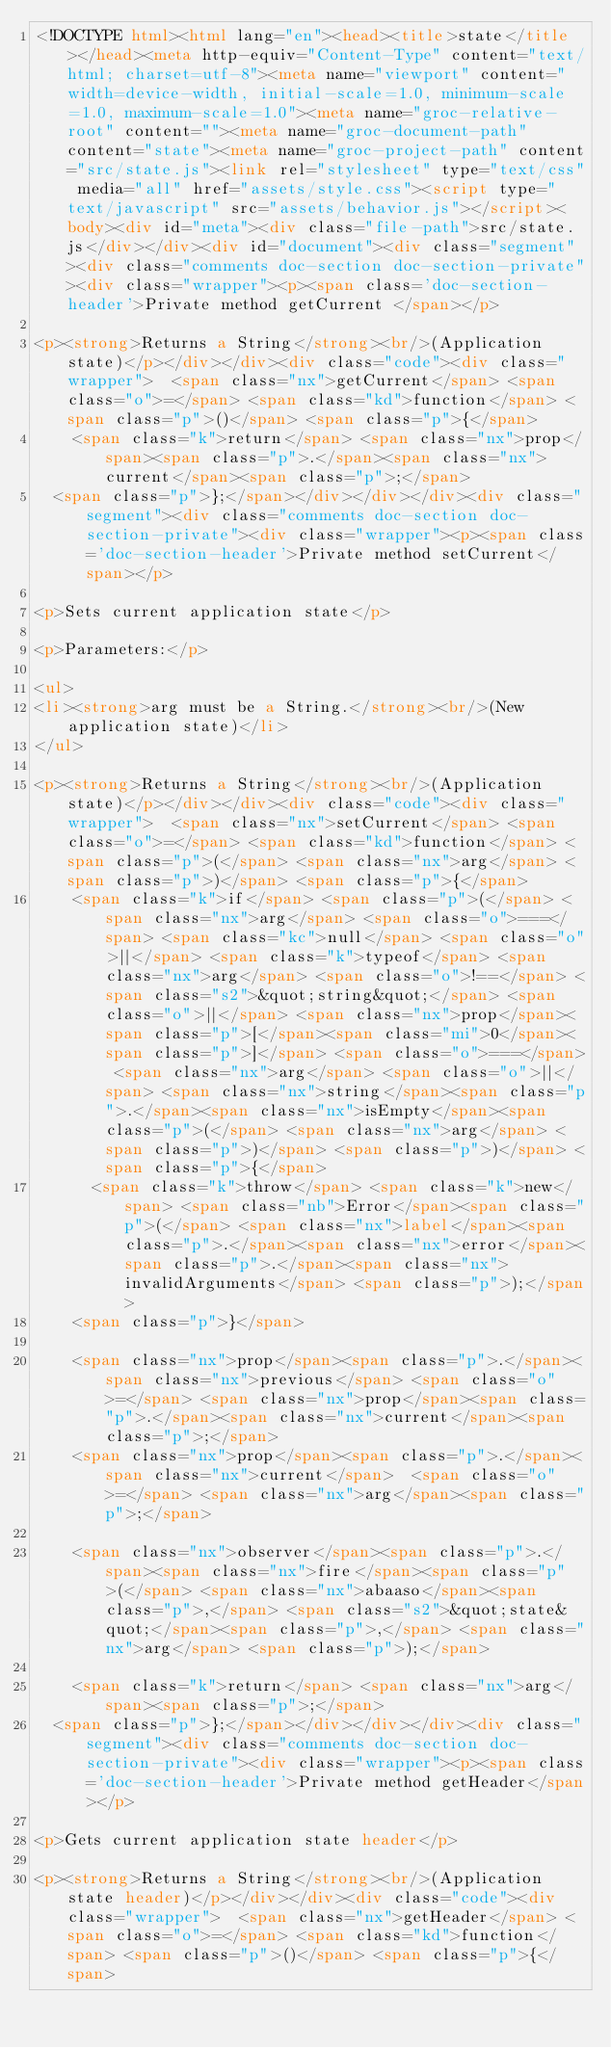<code> <loc_0><loc_0><loc_500><loc_500><_HTML_><!DOCTYPE html><html lang="en"><head><title>state</title></head><meta http-equiv="Content-Type" content="text/html; charset=utf-8"><meta name="viewport" content="width=device-width, initial-scale=1.0, minimum-scale=1.0, maximum-scale=1.0"><meta name="groc-relative-root" content=""><meta name="groc-document-path" content="state"><meta name="groc-project-path" content="src/state.js"><link rel="stylesheet" type="text/css" media="all" href="assets/style.css"><script type="text/javascript" src="assets/behavior.js"></script><body><div id="meta"><div class="file-path">src/state.js</div></div><div id="document"><div class="segment"><div class="comments doc-section doc-section-private"><div class="wrapper"><p><span class='doc-section-header'>Private method getCurrent </span></p>

<p><strong>Returns a String</strong><br/>(Application state)</p></div></div><div class="code"><div class="wrapper">  <span class="nx">getCurrent</span> <span class="o">=</span> <span class="kd">function</span> <span class="p">()</span> <span class="p">{</span>
    <span class="k">return</span> <span class="nx">prop</span><span class="p">.</span><span class="nx">current</span><span class="p">;</span>
  <span class="p">};</span></div></div></div><div class="segment"><div class="comments doc-section doc-section-private"><div class="wrapper"><p><span class='doc-section-header'>Private method setCurrent</span></p>

<p>Sets current application state</p>

<p>Parameters:</p>

<ul>
<li><strong>arg must be a String.</strong><br/>(New application state)</li>
</ul>

<p><strong>Returns a String</strong><br/>(Application state)</p></div></div><div class="code"><div class="wrapper">  <span class="nx">setCurrent</span> <span class="o">=</span> <span class="kd">function</span> <span class="p">(</span> <span class="nx">arg</span> <span class="p">)</span> <span class="p">{</span>
    <span class="k">if</span> <span class="p">(</span> <span class="nx">arg</span> <span class="o">===</span> <span class="kc">null</span> <span class="o">||</span> <span class="k">typeof</span> <span class="nx">arg</span> <span class="o">!==</span> <span class="s2">&quot;string&quot;</span> <span class="o">||</span> <span class="nx">prop</span><span class="p">[</span><span class="mi">0</span><span class="p">]</span> <span class="o">===</span> <span class="nx">arg</span> <span class="o">||</span> <span class="nx">string</span><span class="p">.</span><span class="nx">isEmpty</span><span class="p">(</span> <span class="nx">arg</span> <span class="p">)</span> <span class="p">)</span> <span class="p">{</span>
      <span class="k">throw</span> <span class="k">new</span> <span class="nb">Error</span><span class="p">(</span> <span class="nx">label</span><span class="p">.</span><span class="nx">error</span><span class="p">.</span><span class="nx">invalidArguments</span> <span class="p">);</span>
    <span class="p">}</span>

    <span class="nx">prop</span><span class="p">.</span><span class="nx">previous</span> <span class="o">=</span> <span class="nx">prop</span><span class="p">.</span><span class="nx">current</span><span class="p">;</span>
    <span class="nx">prop</span><span class="p">.</span><span class="nx">current</span>  <span class="o">=</span> <span class="nx">arg</span><span class="p">;</span>

    <span class="nx">observer</span><span class="p">.</span><span class="nx">fire</span><span class="p">(</span> <span class="nx">abaaso</span><span class="p">,</span> <span class="s2">&quot;state&quot;</span><span class="p">,</span> <span class="nx">arg</span> <span class="p">);</span>

    <span class="k">return</span> <span class="nx">arg</span><span class="p">;</span>
  <span class="p">};</span></div></div></div><div class="segment"><div class="comments doc-section doc-section-private"><div class="wrapper"><p><span class='doc-section-header'>Private method getHeader</span></p>

<p>Gets current application state header</p>

<p><strong>Returns a String</strong><br/>(Application state header)</p></div></div><div class="code"><div class="wrapper">  <span class="nx">getHeader</span> <span class="o">=</span> <span class="kd">function</span> <span class="p">()</span> <span class="p">{</span></code> 